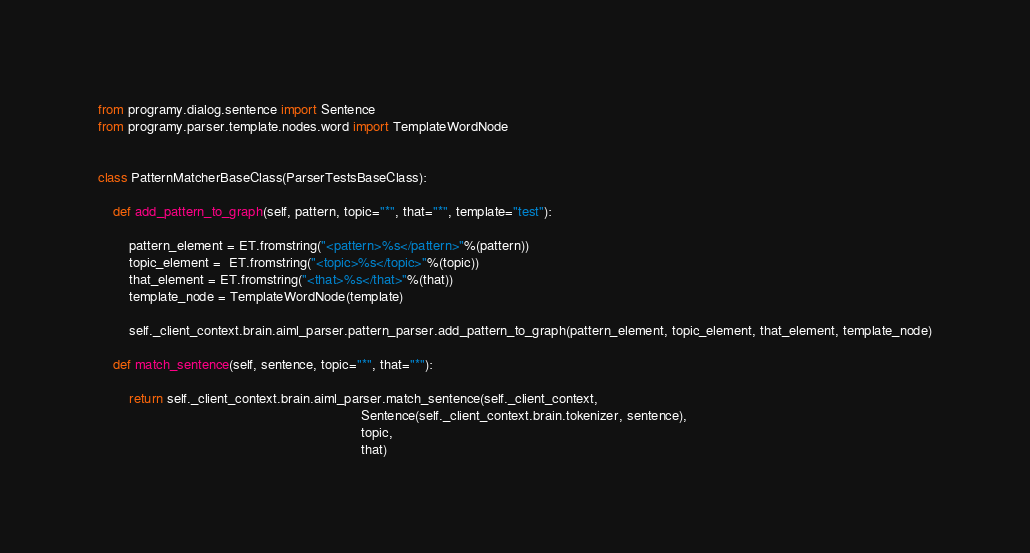<code> <loc_0><loc_0><loc_500><loc_500><_Python_>from programy.dialog.sentence import Sentence
from programy.parser.template.nodes.word import TemplateWordNode


class PatternMatcherBaseClass(ParserTestsBaseClass):

    def add_pattern_to_graph(self, pattern, topic="*", that="*", template="test"):

        pattern_element = ET.fromstring("<pattern>%s</pattern>"%(pattern))
        topic_element =  ET.fromstring("<topic>%s</topic>"%(topic))
        that_element = ET.fromstring("<that>%s</that>"%(that))
        template_node = TemplateWordNode(template)

        self._client_context.brain.aiml_parser.pattern_parser.add_pattern_to_graph(pattern_element, topic_element, that_element, template_node)

    def match_sentence(self, sentence, topic="*", that="*"):

        return self._client_context.brain.aiml_parser.match_sentence(self._client_context,
                                                                     Sentence(self._client_context.brain.tokenizer, sentence),
                                                                     topic,
                                                                     that)</code> 